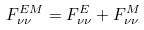Convert formula to latex. <formula><loc_0><loc_0><loc_500><loc_500>F ^ { E M } _ { \nu \nu } = F ^ { E } _ { \nu \nu } + F ^ { M } _ { \nu \nu }</formula> 